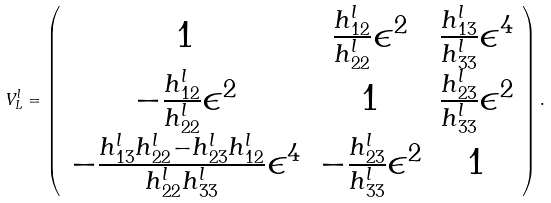Convert formula to latex. <formula><loc_0><loc_0><loc_500><loc_500>V ^ { l } _ { L } = \left ( \begin{array} { c c c } 1 & \frac { h ^ { l } _ { 1 2 } } { h ^ { l } _ { 2 2 } } \epsilon ^ { 2 } & \frac { h ^ { l } _ { 1 3 } } { h ^ { l } _ { 3 3 } } \epsilon ^ { 4 } \\ - \frac { h ^ { l } _ { 1 2 } } { h ^ { l } _ { 2 2 } } \epsilon ^ { 2 } & 1 & \frac { h ^ { l } _ { 2 3 } } { h ^ { l } _ { 3 3 } } \epsilon ^ { 2 } \\ - \frac { h ^ { l } _ { 1 3 } h ^ { l } _ { 2 2 } - h ^ { l } _ { 2 3 } h ^ { l } _ { 1 2 } } { h ^ { l } _ { 2 2 } h ^ { l } _ { 3 3 } } \epsilon ^ { 4 } & - \frac { h ^ { l } _ { 2 3 } } { h ^ { l } _ { 3 3 } } \epsilon ^ { 2 } & 1 \end{array} \right ) .</formula> 